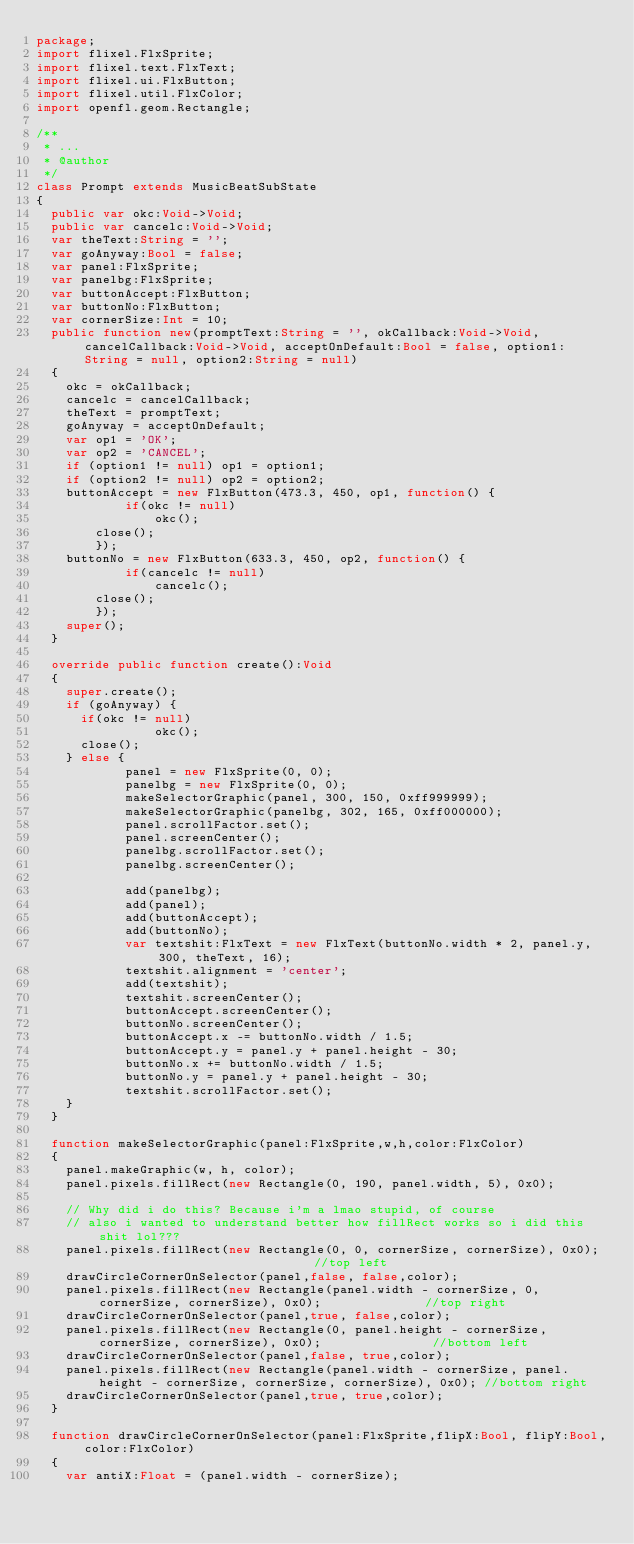Convert code to text. <code><loc_0><loc_0><loc_500><loc_500><_Haxe_>package;
import flixel.FlxSprite;
import flixel.text.FlxText;
import flixel.ui.FlxButton;
import flixel.util.FlxColor;
import openfl.geom.Rectangle;

/**
 * ...
 * @author 
 */
class Prompt extends MusicBeatSubState
{
	public var okc:Void->Void;
	public var cancelc:Void->Void;
	var theText:String = '';
	var goAnyway:Bool = false;
	var panel:FlxSprite;
	var panelbg:FlxSprite;
	var buttonAccept:FlxButton;
	var buttonNo:FlxButton;
	var cornerSize:Int = 10;
	public function new(promptText:String = '', okCallback:Void->Void, cancelCallback:Void->Void, acceptOnDefault:Bool = false, option1:String = null, option2:String = null) 
	{
		okc = okCallback;
		cancelc = cancelCallback;
		theText = promptText;
		goAnyway = acceptOnDefault;
		var op1 = 'OK';
		var op2 = 'CANCEL';
		if (option1 != null) op1 = option1;
		if (option2 != null) op2 = option2;
		buttonAccept = new FlxButton(473.3, 450, op1, function() {
            if(okc != null)
                okc();
	    	close();
        });
		buttonNo = new FlxButton(633.3, 450, op2, function() {
            if(cancelc != null)
                cancelc();
		    close();
        });
		super();	
	}

	override public function create():Void 
	{
		super.create();
		if (goAnyway) {
			if(okc != null)
                okc();
			close();
		} else {
            panel = new FlxSprite(0, 0);
            panelbg = new FlxSprite(0, 0);
            makeSelectorGraphic(panel, 300, 150, 0xff999999);
            makeSelectorGraphic(panelbg, 302, 165, 0xff000000);
            panel.scrollFactor.set();
            panel.screenCenter();
            panelbg.scrollFactor.set();
            panelbg.screenCenter();

            add(panelbg);
            add(panel);
            add(buttonAccept);
            add(buttonNo);
            var textshit:FlxText = new FlxText(buttonNo.width * 2, panel.y, 300, theText, 16);
            textshit.alignment = 'center';
            add(textshit);
            textshit.screenCenter();
            buttonAccept.screenCenter();
            buttonNo.screenCenter();
            buttonAccept.x -= buttonNo.width / 1.5;
            buttonAccept.y = panel.y + panel.height - 30;
            buttonNo.x += buttonNo.width / 1.5;
            buttonNo.y = panel.y + panel.height - 30;
            textshit.scrollFactor.set();
		}
	}

	function makeSelectorGraphic(panel:FlxSprite,w,h,color:FlxColor)
	{
		panel.makeGraphic(w, h, color);
		panel.pixels.fillRect(new Rectangle(0, 190, panel.width, 5), 0x0);

		// Why did i do this? Because i'm a lmao stupid, of course
		// also i wanted to understand better how fillRect works so i did this shit lol???
		panel.pixels.fillRect(new Rectangle(0, 0, cornerSize, cornerSize), 0x0);														 //top left
		drawCircleCornerOnSelector(panel,false, false,color);
		panel.pixels.fillRect(new Rectangle(panel.width - cornerSize, 0, cornerSize, cornerSize), 0x0);							 //top right
		drawCircleCornerOnSelector(panel,true, false,color);
		panel.pixels.fillRect(new Rectangle(0, panel.height - cornerSize, cornerSize, cornerSize), 0x0);							 //bottom left
		drawCircleCornerOnSelector(panel,false, true,color);
		panel.pixels.fillRect(new Rectangle(panel.width - cornerSize, panel.height - cornerSize, cornerSize, cornerSize), 0x0); //bottom right
		drawCircleCornerOnSelector(panel,true, true,color);
	}

	function drawCircleCornerOnSelector(panel:FlxSprite,flipX:Bool, flipY:Bool,color:FlxColor)
	{
		var antiX:Float = (panel.width - cornerSize);</code> 